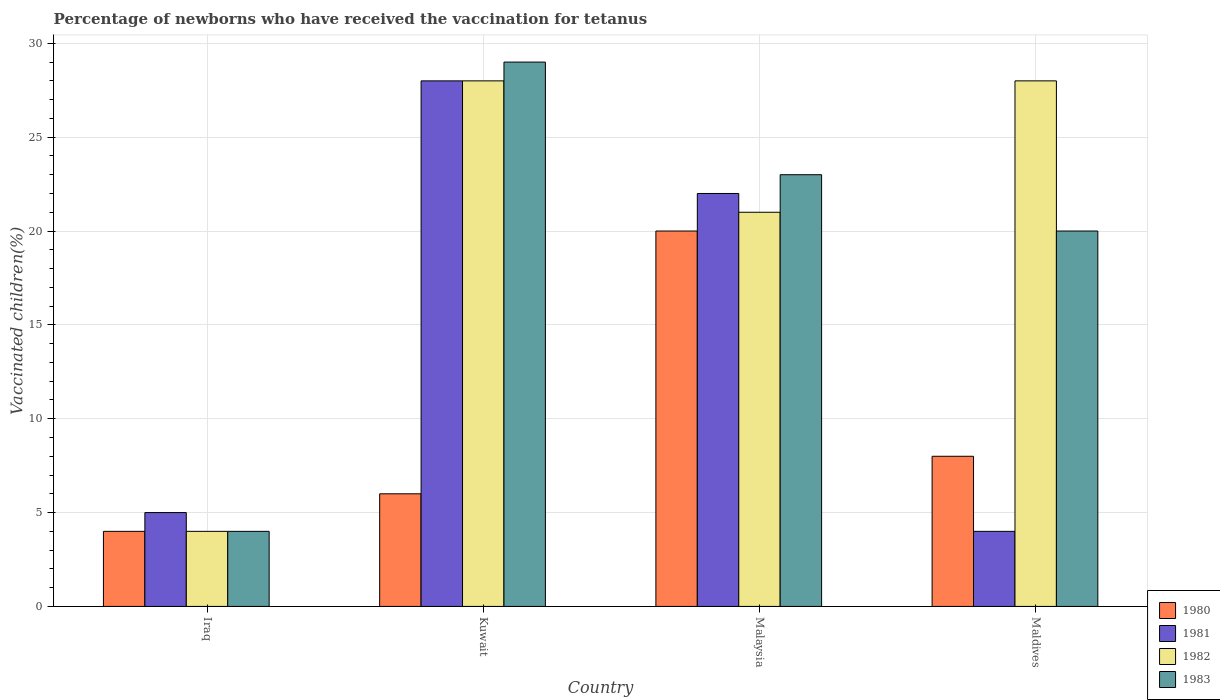How many groups of bars are there?
Your answer should be very brief. 4. Are the number of bars per tick equal to the number of legend labels?
Provide a short and direct response. Yes. Are the number of bars on each tick of the X-axis equal?
Your answer should be very brief. Yes. How many bars are there on the 4th tick from the right?
Provide a short and direct response. 4. What is the label of the 2nd group of bars from the left?
Make the answer very short. Kuwait. In how many cases, is the number of bars for a given country not equal to the number of legend labels?
Provide a short and direct response. 0. Across all countries, what is the minimum percentage of vaccinated children in 1983?
Your answer should be very brief. 4. In which country was the percentage of vaccinated children in 1983 maximum?
Offer a very short reply. Kuwait. In which country was the percentage of vaccinated children in 1982 minimum?
Offer a terse response. Iraq. What is the total percentage of vaccinated children in 1982 in the graph?
Keep it short and to the point. 81. What is the average percentage of vaccinated children in 1982 per country?
Ensure brevity in your answer.  20.25. What is the ratio of the percentage of vaccinated children in 1981 in Iraq to that in Malaysia?
Provide a succinct answer. 0.23. Is the difference between the percentage of vaccinated children in 1983 in Iraq and Kuwait greater than the difference between the percentage of vaccinated children in 1980 in Iraq and Kuwait?
Provide a short and direct response. No. What is the difference between the highest and the lowest percentage of vaccinated children in 1980?
Offer a terse response. 16. Is it the case that in every country, the sum of the percentage of vaccinated children in 1983 and percentage of vaccinated children in 1980 is greater than the sum of percentage of vaccinated children in 1982 and percentage of vaccinated children in 1981?
Keep it short and to the point. No. What does the 4th bar from the left in Malaysia represents?
Offer a terse response. 1983. Is it the case that in every country, the sum of the percentage of vaccinated children in 1980 and percentage of vaccinated children in 1982 is greater than the percentage of vaccinated children in 1981?
Ensure brevity in your answer.  Yes. How many bars are there?
Offer a very short reply. 16. Are all the bars in the graph horizontal?
Ensure brevity in your answer.  No. Are the values on the major ticks of Y-axis written in scientific E-notation?
Give a very brief answer. No. Where does the legend appear in the graph?
Keep it short and to the point. Bottom right. What is the title of the graph?
Your answer should be compact. Percentage of newborns who have received the vaccination for tetanus. What is the label or title of the Y-axis?
Offer a terse response. Vaccinated children(%). What is the Vaccinated children(%) in 1980 in Kuwait?
Provide a short and direct response. 6. What is the Vaccinated children(%) in 1982 in Kuwait?
Offer a terse response. 28. What is the Vaccinated children(%) of 1982 in Malaysia?
Provide a succinct answer. 21. What is the Vaccinated children(%) in 1983 in Malaysia?
Your answer should be compact. 23. What is the Vaccinated children(%) in 1980 in Maldives?
Your response must be concise. 8. What is the Vaccinated children(%) in 1982 in Maldives?
Offer a very short reply. 28. What is the Vaccinated children(%) of 1983 in Maldives?
Provide a short and direct response. 20. Across all countries, what is the maximum Vaccinated children(%) of 1981?
Provide a short and direct response. 28. Across all countries, what is the maximum Vaccinated children(%) of 1983?
Your response must be concise. 29. Across all countries, what is the minimum Vaccinated children(%) in 1983?
Your response must be concise. 4. What is the total Vaccinated children(%) in 1980 in the graph?
Offer a terse response. 38. What is the total Vaccinated children(%) in 1981 in the graph?
Make the answer very short. 59. What is the total Vaccinated children(%) of 1982 in the graph?
Provide a short and direct response. 81. What is the total Vaccinated children(%) of 1983 in the graph?
Give a very brief answer. 76. What is the difference between the Vaccinated children(%) of 1983 in Iraq and that in Kuwait?
Your answer should be very brief. -25. What is the difference between the Vaccinated children(%) of 1980 in Iraq and that in Malaysia?
Your response must be concise. -16. What is the difference between the Vaccinated children(%) in 1982 in Iraq and that in Malaysia?
Your answer should be very brief. -17. What is the difference between the Vaccinated children(%) in 1983 in Iraq and that in Malaysia?
Your answer should be very brief. -19. What is the difference between the Vaccinated children(%) in 1981 in Iraq and that in Maldives?
Provide a succinct answer. 1. What is the difference between the Vaccinated children(%) of 1982 in Iraq and that in Maldives?
Your answer should be compact. -24. What is the difference between the Vaccinated children(%) of 1980 in Kuwait and that in Malaysia?
Offer a very short reply. -14. What is the difference between the Vaccinated children(%) of 1982 in Kuwait and that in Malaysia?
Give a very brief answer. 7. What is the difference between the Vaccinated children(%) of 1983 in Kuwait and that in Malaysia?
Give a very brief answer. 6. What is the difference between the Vaccinated children(%) in 1981 in Kuwait and that in Maldives?
Provide a succinct answer. 24. What is the difference between the Vaccinated children(%) of 1983 in Kuwait and that in Maldives?
Offer a terse response. 9. What is the difference between the Vaccinated children(%) in 1980 in Malaysia and that in Maldives?
Give a very brief answer. 12. What is the difference between the Vaccinated children(%) in 1983 in Malaysia and that in Maldives?
Give a very brief answer. 3. What is the difference between the Vaccinated children(%) in 1981 in Iraq and the Vaccinated children(%) in 1982 in Kuwait?
Provide a short and direct response. -23. What is the difference between the Vaccinated children(%) in 1980 in Iraq and the Vaccinated children(%) in 1981 in Maldives?
Offer a very short reply. 0. What is the difference between the Vaccinated children(%) in 1980 in Iraq and the Vaccinated children(%) in 1982 in Maldives?
Your response must be concise. -24. What is the difference between the Vaccinated children(%) of 1981 in Iraq and the Vaccinated children(%) of 1982 in Maldives?
Your answer should be compact. -23. What is the difference between the Vaccinated children(%) of 1981 in Iraq and the Vaccinated children(%) of 1983 in Maldives?
Provide a short and direct response. -15. What is the difference between the Vaccinated children(%) in 1982 in Iraq and the Vaccinated children(%) in 1983 in Maldives?
Offer a terse response. -16. What is the difference between the Vaccinated children(%) of 1980 in Kuwait and the Vaccinated children(%) of 1982 in Malaysia?
Keep it short and to the point. -15. What is the difference between the Vaccinated children(%) of 1980 in Kuwait and the Vaccinated children(%) of 1983 in Malaysia?
Make the answer very short. -17. What is the difference between the Vaccinated children(%) in 1982 in Kuwait and the Vaccinated children(%) in 1983 in Malaysia?
Ensure brevity in your answer.  5. What is the difference between the Vaccinated children(%) in 1980 in Kuwait and the Vaccinated children(%) in 1981 in Maldives?
Give a very brief answer. 2. What is the difference between the Vaccinated children(%) of 1980 in Kuwait and the Vaccinated children(%) of 1982 in Maldives?
Give a very brief answer. -22. What is the difference between the Vaccinated children(%) of 1980 in Kuwait and the Vaccinated children(%) of 1983 in Maldives?
Provide a short and direct response. -14. What is the difference between the Vaccinated children(%) in 1981 in Kuwait and the Vaccinated children(%) in 1982 in Maldives?
Provide a succinct answer. 0. What is the difference between the Vaccinated children(%) in 1981 in Kuwait and the Vaccinated children(%) in 1983 in Maldives?
Your answer should be compact. 8. What is the difference between the Vaccinated children(%) of 1982 in Kuwait and the Vaccinated children(%) of 1983 in Maldives?
Provide a succinct answer. 8. What is the difference between the Vaccinated children(%) of 1980 in Malaysia and the Vaccinated children(%) of 1981 in Maldives?
Your answer should be very brief. 16. What is the difference between the Vaccinated children(%) in 1980 in Malaysia and the Vaccinated children(%) in 1982 in Maldives?
Keep it short and to the point. -8. What is the difference between the Vaccinated children(%) in 1981 in Malaysia and the Vaccinated children(%) in 1982 in Maldives?
Your answer should be compact. -6. What is the difference between the Vaccinated children(%) of 1982 in Malaysia and the Vaccinated children(%) of 1983 in Maldives?
Your answer should be compact. 1. What is the average Vaccinated children(%) of 1980 per country?
Provide a short and direct response. 9.5. What is the average Vaccinated children(%) of 1981 per country?
Give a very brief answer. 14.75. What is the average Vaccinated children(%) in 1982 per country?
Give a very brief answer. 20.25. What is the average Vaccinated children(%) in 1983 per country?
Make the answer very short. 19. What is the difference between the Vaccinated children(%) in 1980 and Vaccinated children(%) in 1982 in Iraq?
Offer a terse response. 0. What is the difference between the Vaccinated children(%) in 1981 and Vaccinated children(%) in 1982 in Iraq?
Make the answer very short. 1. What is the difference between the Vaccinated children(%) of 1980 and Vaccinated children(%) of 1981 in Kuwait?
Give a very brief answer. -22. What is the difference between the Vaccinated children(%) of 1982 and Vaccinated children(%) of 1983 in Kuwait?
Provide a short and direct response. -1. What is the difference between the Vaccinated children(%) of 1980 and Vaccinated children(%) of 1983 in Malaysia?
Ensure brevity in your answer.  -3. What is the difference between the Vaccinated children(%) in 1981 and Vaccinated children(%) in 1982 in Malaysia?
Give a very brief answer. 1. What is the difference between the Vaccinated children(%) of 1980 and Vaccinated children(%) of 1981 in Maldives?
Offer a very short reply. 4. What is the difference between the Vaccinated children(%) of 1981 and Vaccinated children(%) of 1983 in Maldives?
Offer a terse response. -16. What is the ratio of the Vaccinated children(%) in 1981 in Iraq to that in Kuwait?
Ensure brevity in your answer.  0.18. What is the ratio of the Vaccinated children(%) in 1982 in Iraq to that in Kuwait?
Give a very brief answer. 0.14. What is the ratio of the Vaccinated children(%) in 1983 in Iraq to that in Kuwait?
Your response must be concise. 0.14. What is the ratio of the Vaccinated children(%) in 1981 in Iraq to that in Malaysia?
Ensure brevity in your answer.  0.23. What is the ratio of the Vaccinated children(%) of 1982 in Iraq to that in Malaysia?
Offer a very short reply. 0.19. What is the ratio of the Vaccinated children(%) in 1983 in Iraq to that in Malaysia?
Offer a terse response. 0.17. What is the ratio of the Vaccinated children(%) of 1980 in Iraq to that in Maldives?
Give a very brief answer. 0.5. What is the ratio of the Vaccinated children(%) in 1982 in Iraq to that in Maldives?
Your answer should be compact. 0.14. What is the ratio of the Vaccinated children(%) in 1983 in Iraq to that in Maldives?
Make the answer very short. 0.2. What is the ratio of the Vaccinated children(%) of 1980 in Kuwait to that in Malaysia?
Provide a succinct answer. 0.3. What is the ratio of the Vaccinated children(%) in 1981 in Kuwait to that in Malaysia?
Give a very brief answer. 1.27. What is the ratio of the Vaccinated children(%) of 1983 in Kuwait to that in Malaysia?
Offer a terse response. 1.26. What is the ratio of the Vaccinated children(%) in 1980 in Kuwait to that in Maldives?
Provide a short and direct response. 0.75. What is the ratio of the Vaccinated children(%) in 1981 in Kuwait to that in Maldives?
Offer a very short reply. 7. What is the ratio of the Vaccinated children(%) in 1983 in Kuwait to that in Maldives?
Provide a succinct answer. 1.45. What is the ratio of the Vaccinated children(%) of 1980 in Malaysia to that in Maldives?
Offer a very short reply. 2.5. What is the ratio of the Vaccinated children(%) in 1981 in Malaysia to that in Maldives?
Make the answer very short. 5.5. What is the ratio of the Vaccinated children(%) in 1982 in Malaysia to that in Maldives?
Your answer should be compact. 0.75. What is the ratio of the Vaccinated children(%) in 1983 in Malaysia to that in Maldives?
Provide a short and direct response. 1.15. What is the difference between the highest and the second highest Vaccinated children(%) in 1980?
Offer a very short reply. 12. What is the difference between the highest and the second highest Vaccinated children(%) in 1983?
Provide a succinct answer. 6. What is the difference between the highest and the lowest Vaccinated children(%) in 1980?
Your response must be concise. 16. What is the difference between the highest and the lowest Vaccinated children(%) in 1983?
Your answer should be compact. 25. 